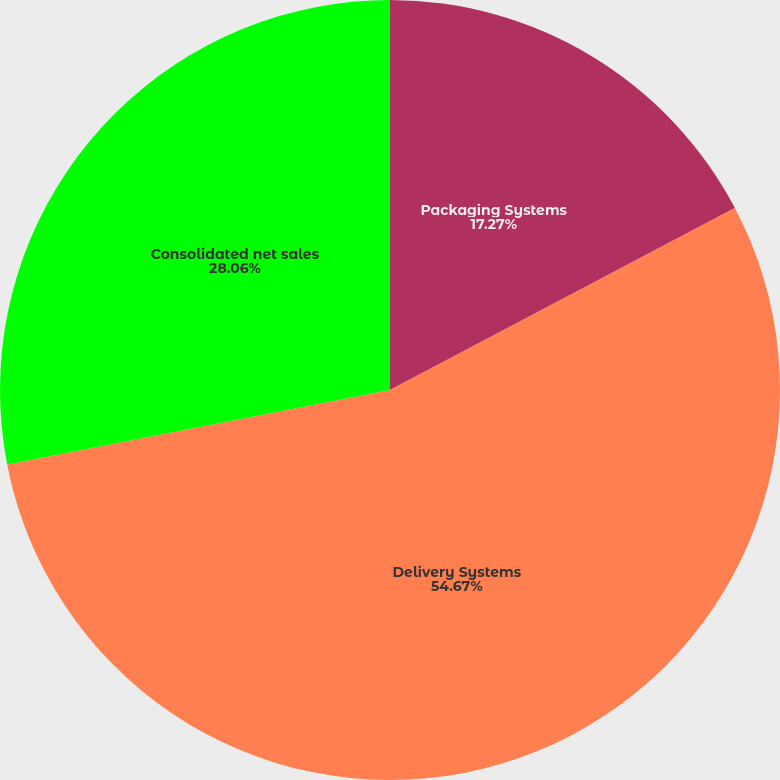<chart> <loc_0><loc_0><loc_500><loc_500><pie_chart><fcel>Packaging Systems<fcel>Delivery Systems<fcel>Consolidated net sales<nl><fcel>17.27%<fcel>54.68%<fcel>28.06%<nl></chart> 